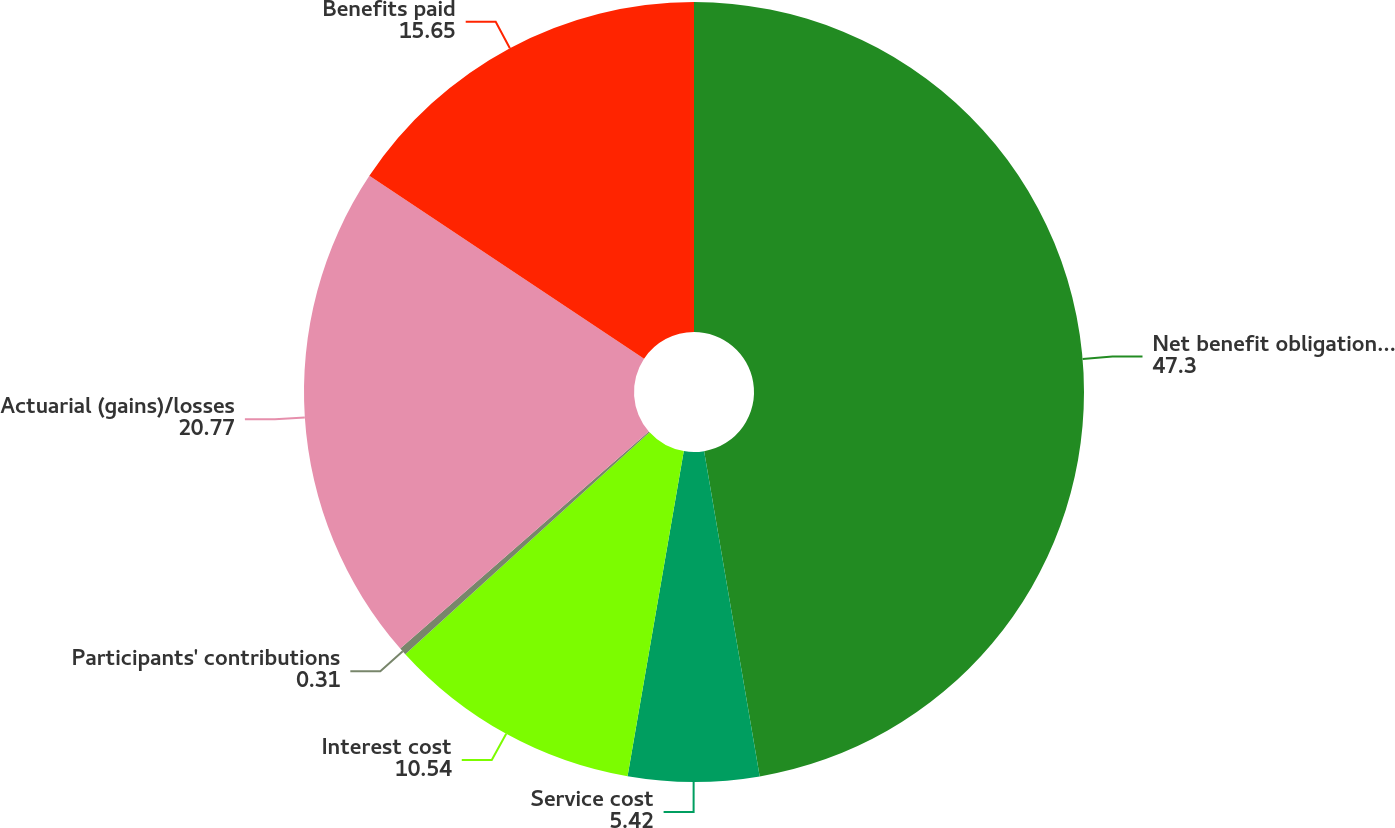Convert chart to OTSL. <chart><loc_0><loc_0><loc_500><loc_500><pie_chart><fcel>Net benefit obligation at the<fcel>Service cost<fcel>Interest cost<fcel>Participants' contributions<fcel>Actuarial (gains)/losses<fcel>Benefits paid<nl><fcel>47.3%<fcel>5.42%<fcel>10.54%<fcel>0.31%<fcel>20.77%<fcel>15.65%<nl></chart> 